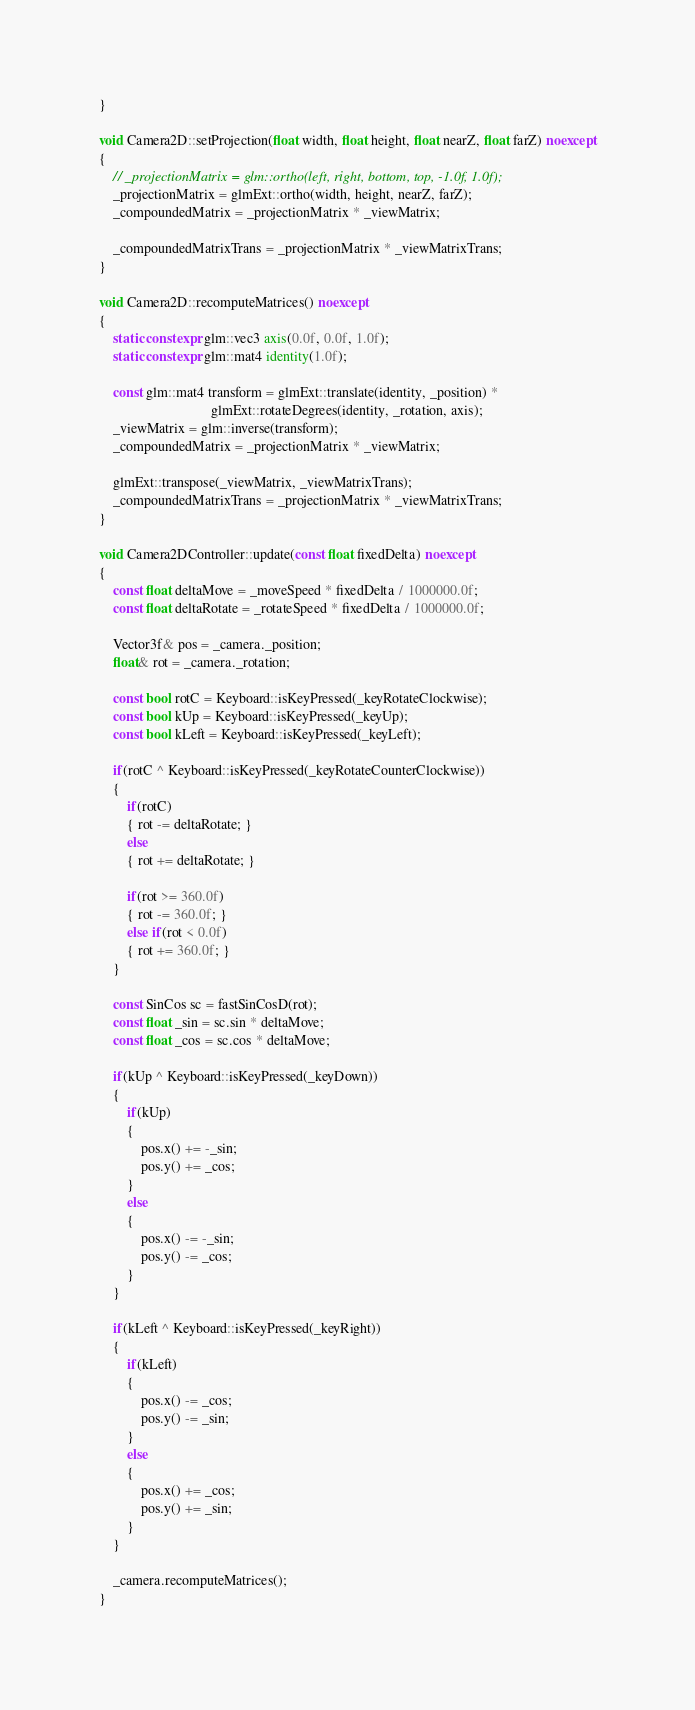<code> <loc_0><loc_0><loc_500><loc_500><_C++_>}

void Camera2D::setProjection(float width, float height, float nearZ, float farZ) noexcept
{
    // _projectionMatrix = glm::ortho(left, right, bottom, top, -1.0f, 1.0f);
    _projectionMatrix = glmExt::ortho(width, height, nearZ, farZ);
    _compoundedMatrix = _projectionMatrix * _viewMatrix;

    _compoundedMatrixTrans = _projectionMatrix * _viewMatrixTrans;
}

void Camera2D::recomputeMatrices() noexcept
{
    static constexpr glm::vec3 axis(0.0f, 0.0f, 1.0f);
    static constexpr glm::mat4 identity(1.0f);

    const glm::mat4 transform = glmExt::translate(identity, _position) * 
                                glmExt::rotateDegrees(identity, _rotation, axis);
    _viewMatrix = glm::inverse(transform);
    _compoundedMatrix = _projectionMatrix * _viewMatrix;

    glmExt::transpose(_viewMatrix, _viewMatrixTrans);
    _compoundedMatrixTrans = _projectionMatrix * _viewMatrixTrans;
}

void Camera2DController::update(const float fixedDelta) noexcept
{
    const float deltaMove = _moveSpeed * fixedDelta / 1000000.0f;
    const float deltaRotate = _rotateSpeed * fixedDelta / 1000000.0f;

    Vector3f& pos = _camera._position;
    float& rot = _camera._rotation;

    const bool rotC = Keyboard::isKeyPressed(_keyRotateClockwise);
    const bool kUp = Keyboard::isKeyPressed(_keyUp);
    const bool kLeft = Keyboard::isKeyPressed(_keyLeft);

    if(rotC ^ Keyboard::isKeyPressed(_keyRotateCounterClockwise))
    {
        if(rotC)
        { rot -= deltaRotate; }
        else
        { rot += deltaRotate; }

        if(rot >= 360.0f)
        { rot -= 360.0f; }
        else if(rot < 0.0f)
        { rot += 360.0f; }
    }

    const SinCos sc = fastSinCosD(rot);
    const float _sin = sc.sin * deltaMove;
    const float _cos = sc.cos * deltaMove;

    if(kUp ^ Keyboard::isKeyPressed(_keyDown))
    {
        if(kUp)
        {
            pos.x() += -_sin;
            pos.y() += _cos;
        }
        else
        {
            pos.x() -= -_sin;
            pos.y() -= _cos;
        }
    }

    if(kLeft ^ Keyboard::isKeyPressed(_keyRight))
    {
        if(kLeft)
        {
            pos.x() -= _cos;
            pos.y() -= _sin;
        }
        else
        {
            pos.x() += _cos;
            pos.y() += _sin;
        }
    }

    _camera.recomputeMatrices();
}
</code> 